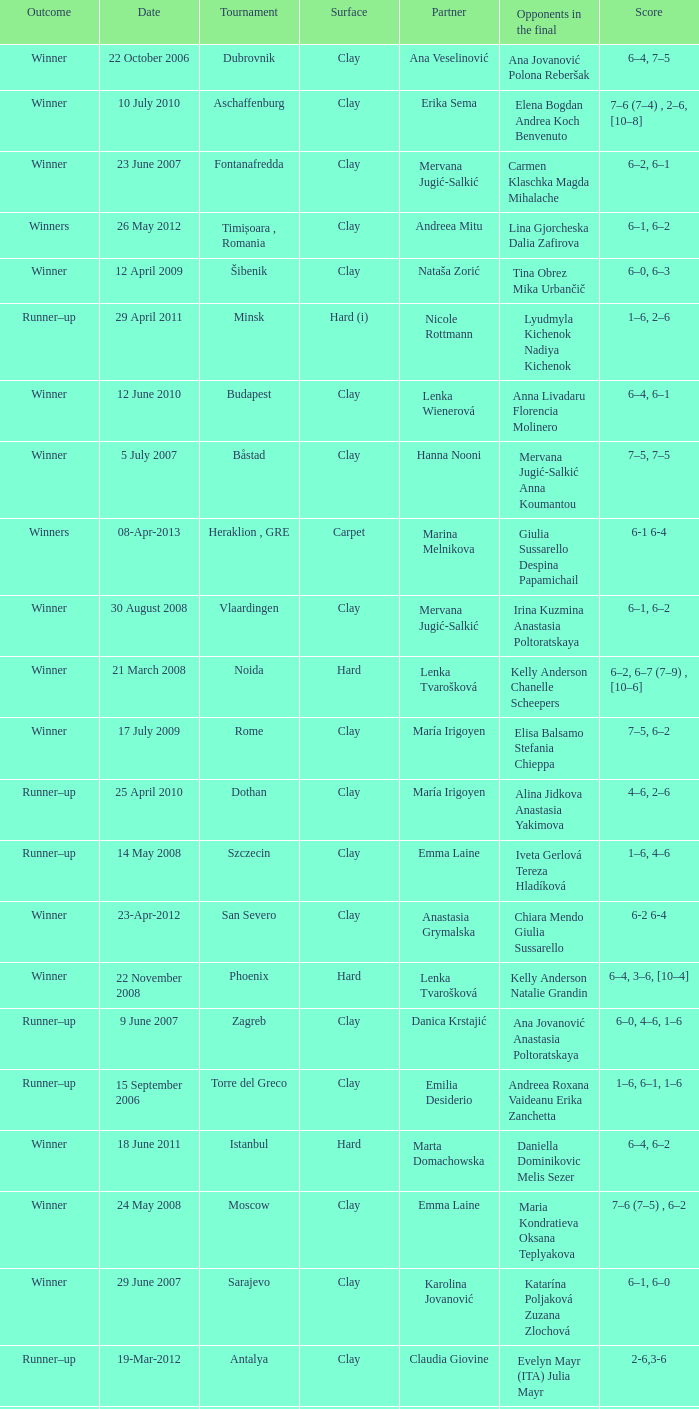Who were the opponents in the final at Noida? Kelly Anderson Chanelle Scheepers. 